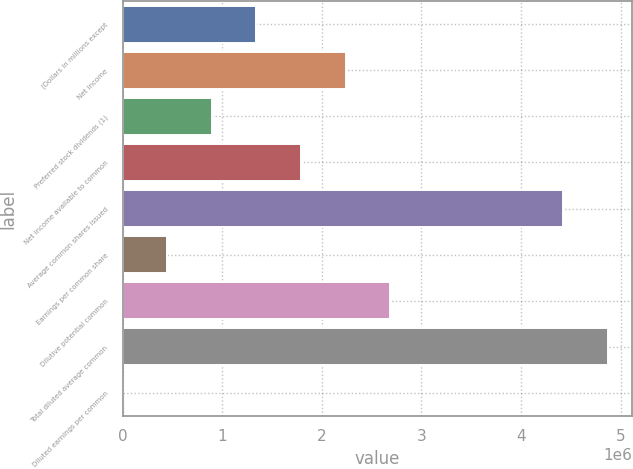Convert chart to OTSL. <chart><loc_0><loc_0><loc_500><loc_500><bar_chart><fcel>(Dollars in millions except<fcel>Net income<fcel>Preferred stock dividends (1)<fcel>Net income available to common<fcel>Average common shares issued<fcel>Earnings per common share<fcel>Dilutive potential common<fcel>Total diluted average common<fcel>Diluted earnings per common<nl><fcel>1.34408e+06<fcel>2.24013e+06<fcel>896053<fcel>1.7921e+06<fcel>4.42358e+06<fcel>448028<fcel>2.68815e+06<fcel>4.8716e+06<fcel>3.3<nl></chart> 